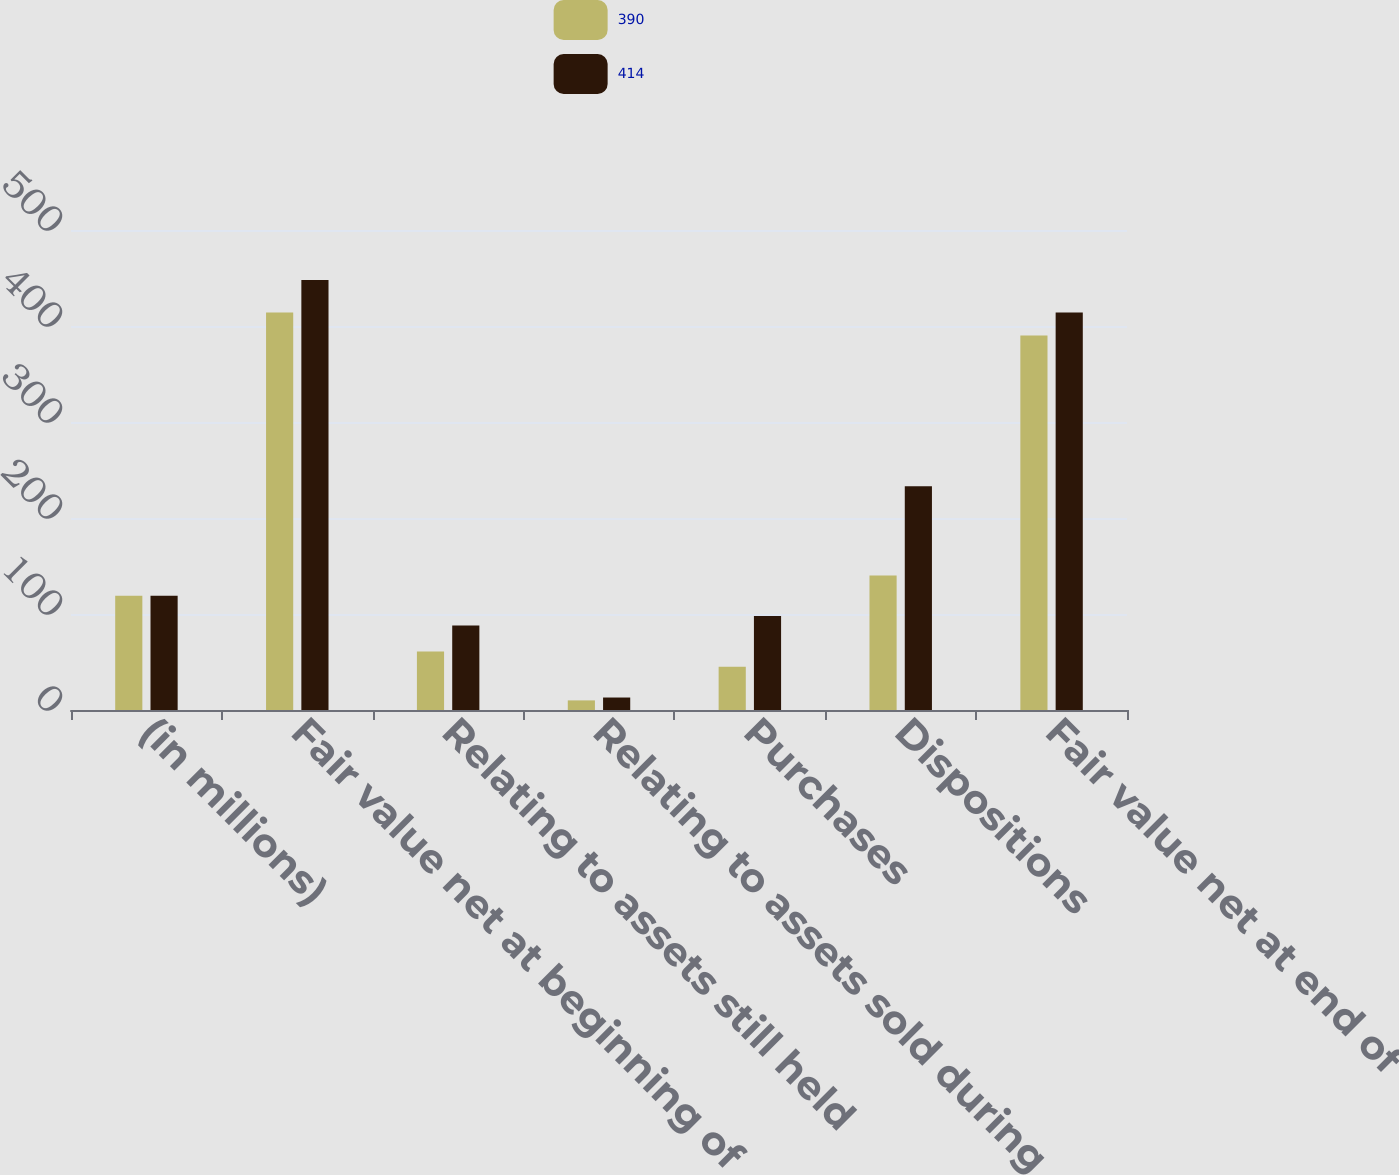Convert chart. <chart><loc_0><loc_0><loc_500><loc_500><stacked_bar_chart><ecel><fcel>(in millions)<fcel>Fair value net at beginning of<fcel>Relating to assets still held<fcel>Relating to assets sold during<fcel>Purchases<fcel>Dispositions<fcel>Fair value net at end of<nl><fcel>390<fcel>119<fcel>414<fcel>61<fcel>10<fcel>45<fcel>140<fcel>390<nl><fcel>414<fcel>119<fcel>448<fcel>88<fcel>13<fcel>98<fcel>233<fcel>414<nl></chart> 